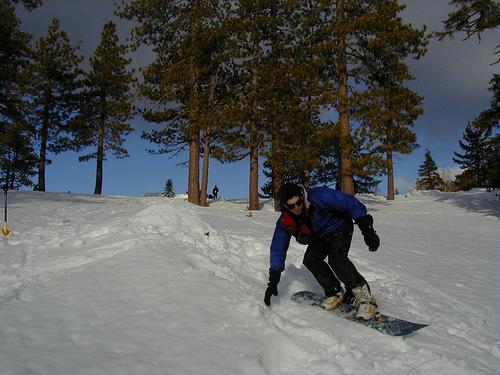What is covering the ground?
Quick response, please. Snow. Which direction is the man traveling?
Keep it brief. Down. What is the man doing in the snow?
Answer briefly. Snowboarding. Is the man skiing?
Quick response, please. No. Does this person look in the air or on the ground?
Short answer required. Ground. What is the person doing?
Concise answer only. Snowboarding. What color is the man's jacket?
Concise answer only. Blue. What winter activity is the man partaking in?
Concise answer only. Snowboarding. 